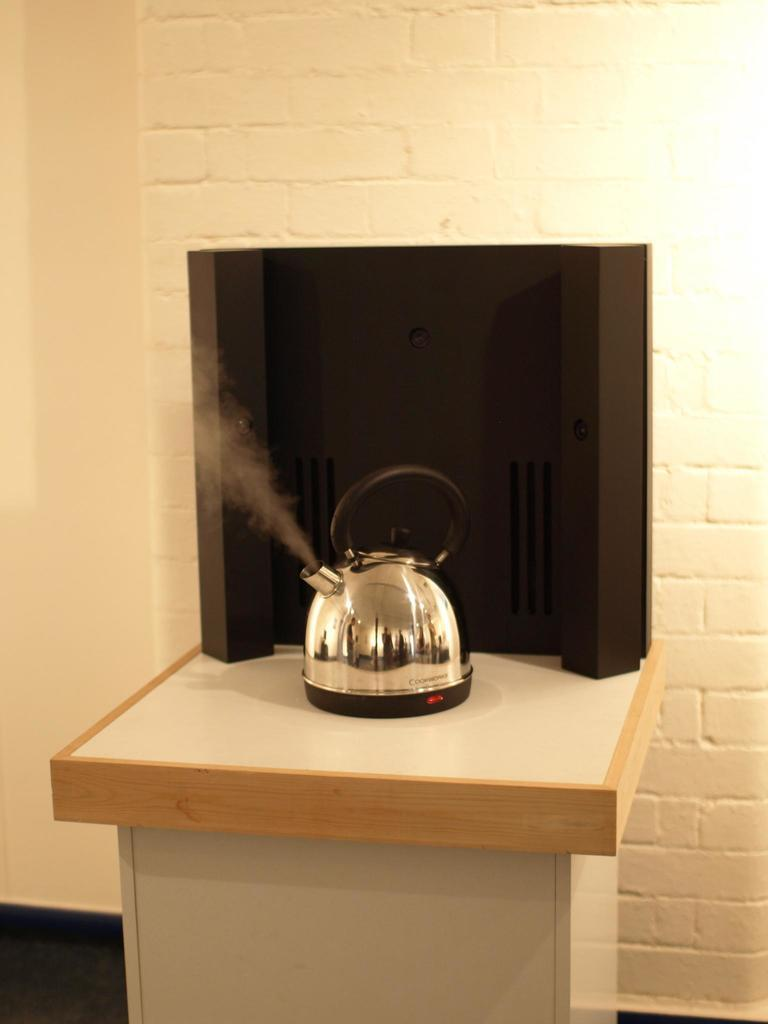What is the main object in the image? There is a kettle in the image. Where is the kettle located? The kettle is on a table. What is behind the table in the image? The table is in front of a wall. How much profit does the kettle generate in the image? The image does not provide any information about the kettle generating profit, as it is an inanimate object. 